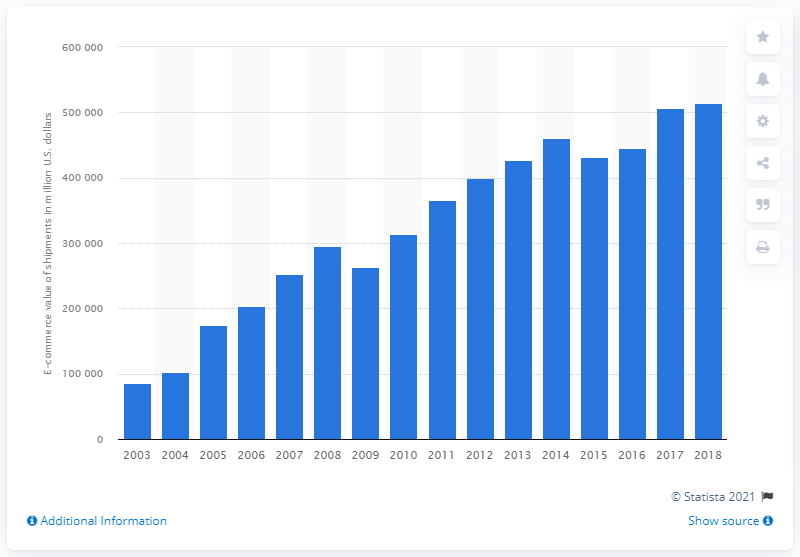Point out several critical features in this image. The value of B2B e-commerce shipments in the chemical manufacturing industry in the United States was approximately 514,533 in 2018. 